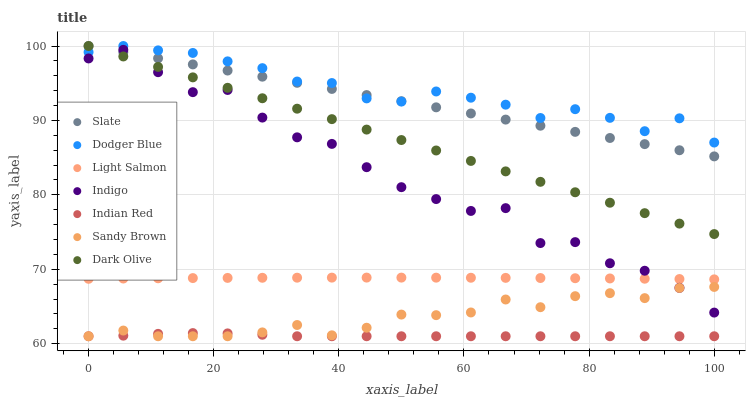Does Indian Red have the minimum area under the curve?
Answer yes or no. Yes. Does Dodger Blue have the maximum area under the curve?
Answer yes or no. Yes. Does Indigo have the minimum area under the curve?
Answer yes or no. No. Does Indigo have the maximum area under the curve?
Answer yes or no. No. Is Slate the smoothest?
Answer yes or no. Yes. Is Indigo the roughest?
Answer yes or no. Yes. Is Indigo the smoothest?
Answer yes or no. No. Is Slate the roughest?
Answer yes or no. No. Does Indian Red have the lowest value?
Answer yes or no. Yes. Does Indigo have the lowest value?
Answer yes or no. No. Does Dodger Blue have the highest value?
Answer yes or no. Yes. Does Indigo have the highest value?
Answer yes or no. No. Is Indigo less than Dodger Blue?
Answer yes or no. Yes. Is Slate greater than Light Salmon?
Answer yes or no. Yes. Does Indigo intersect Light Salmon?
Answer yes or no. Yes. Is Indigo less than Light Salmon?
Answer yes or no. No. Is Indigo greater than Light Salmon?
Answer yes or no. No. Does Indigo intersect Dodger Blue?
Answer yes or no. No. 